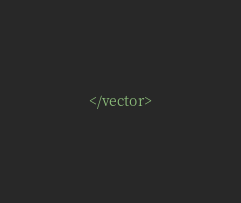<code> <loc_0><loc_0><loc_500><loc_500><_XML_></vector>
</code> 